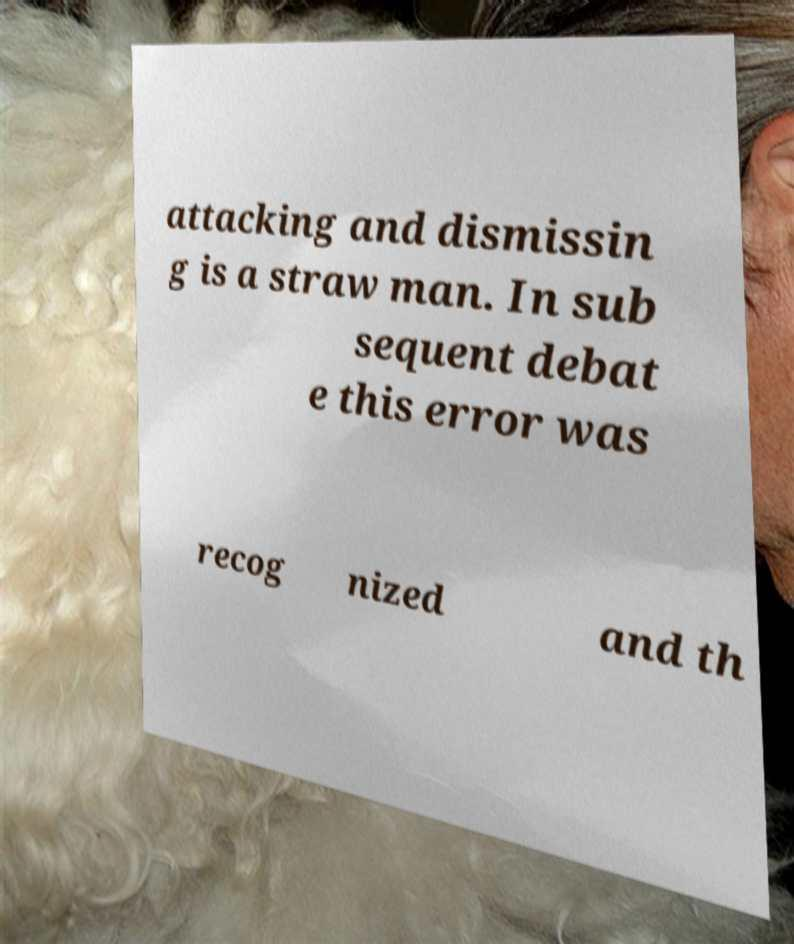What messages or text are displayed in this image? I need them in a readable, typed format. attacking and dismissin g is a straw man. In sub sequent debat e this error was recog nized and th 